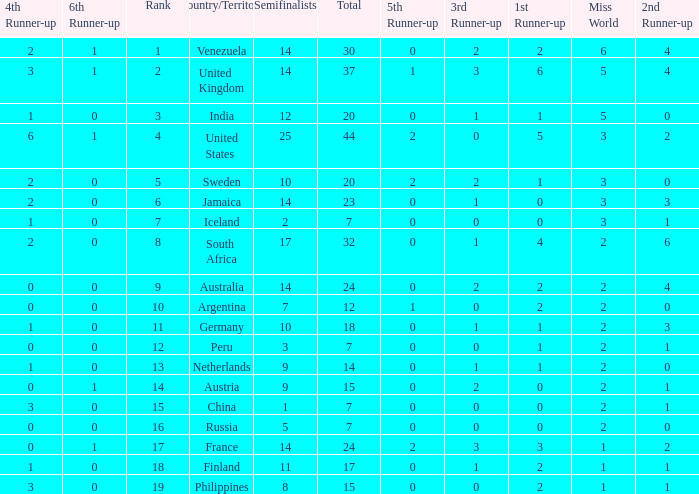What is Iceland's total? 1.0. 